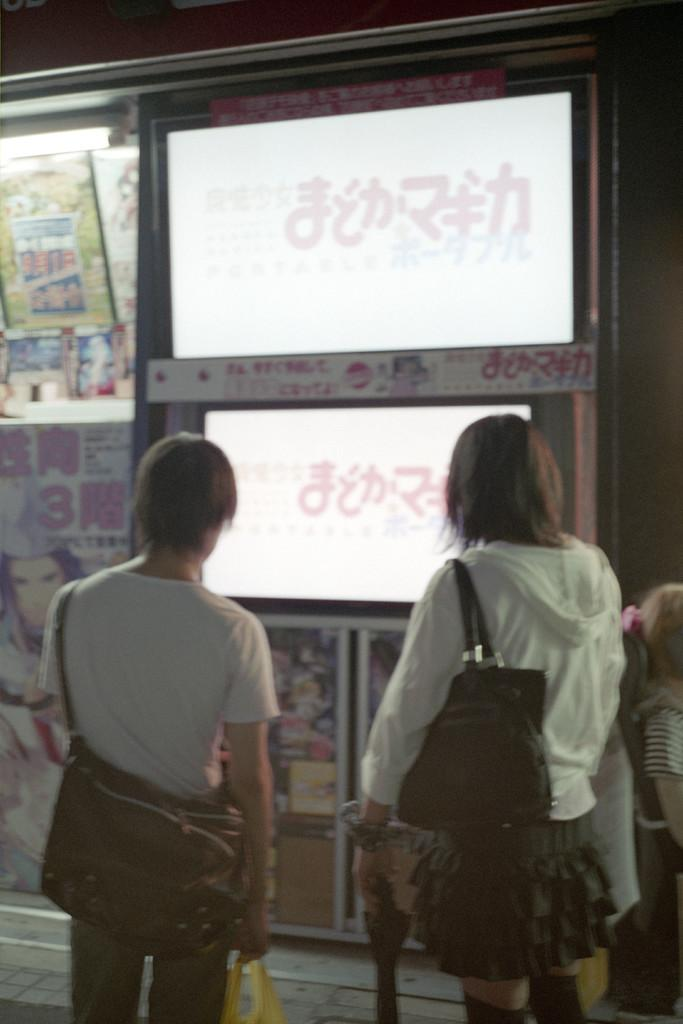How many people are in the image? There are two persons in the image. What are the persons wearing? The persons are wearing bags. What are the persons holding? The persons are holding an object. What can be seen in the background of the image? There is a display board and posters in the image. What type of light is visible in the image? There is a light in the image. Are the persons in the image spying on someone? There is no indication in the image that the persons are spying on someone. How do the persons in the image express disgust? There is no indication of disgust in the image; the persons are simply holding an object. 